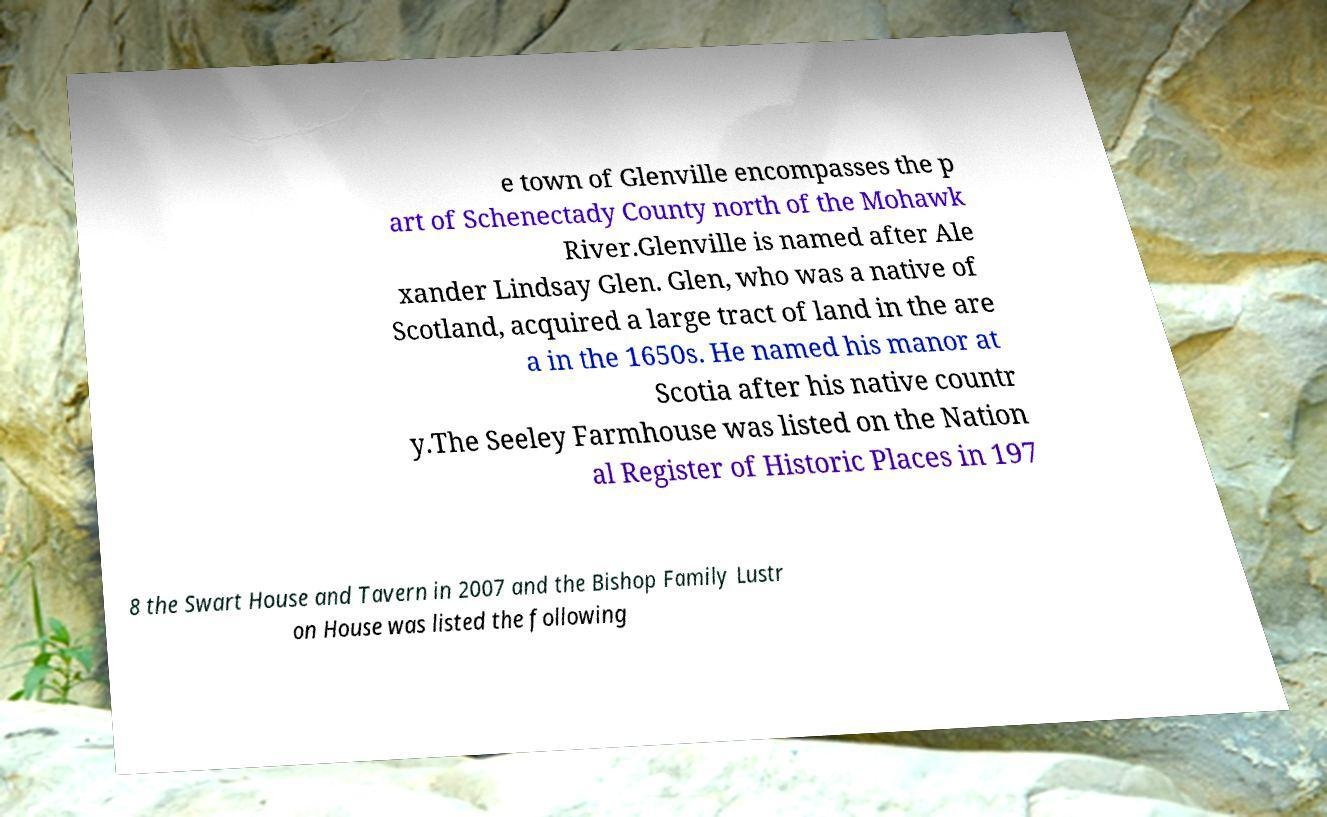I need the written content from this picture converted into text. Can you do that? e town of Glenville encompasses the p art of Schenectady County north of the Mohawk River.Glenville is named after Ale xander Lindsay Glen. Glen, who was a native of Scotland, acquired a large tract of land in the are a in the 1650s. He named his manor at Scotia after his native countr y.The Seeley Farmhouse was listed on the Nation al Register of Historic Places in 197 8 the Swart House and Tavern in 2007 and the Bishop Family Lustr on House was listed the following 